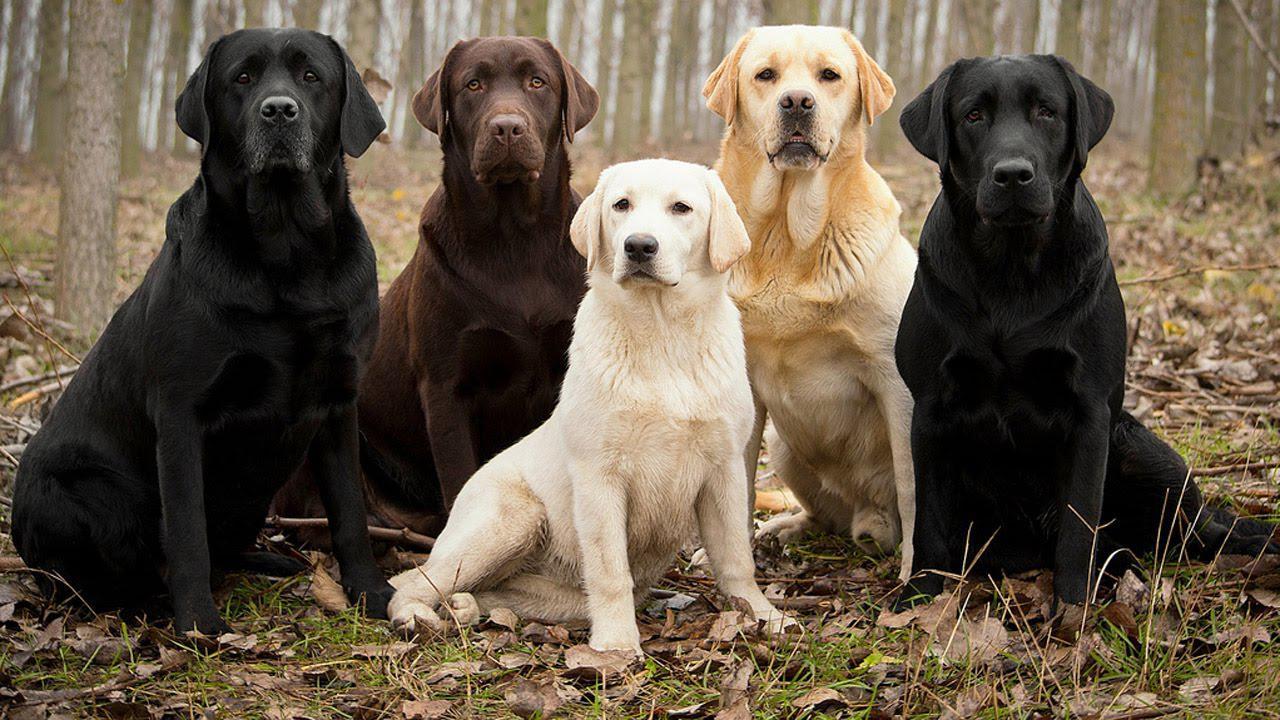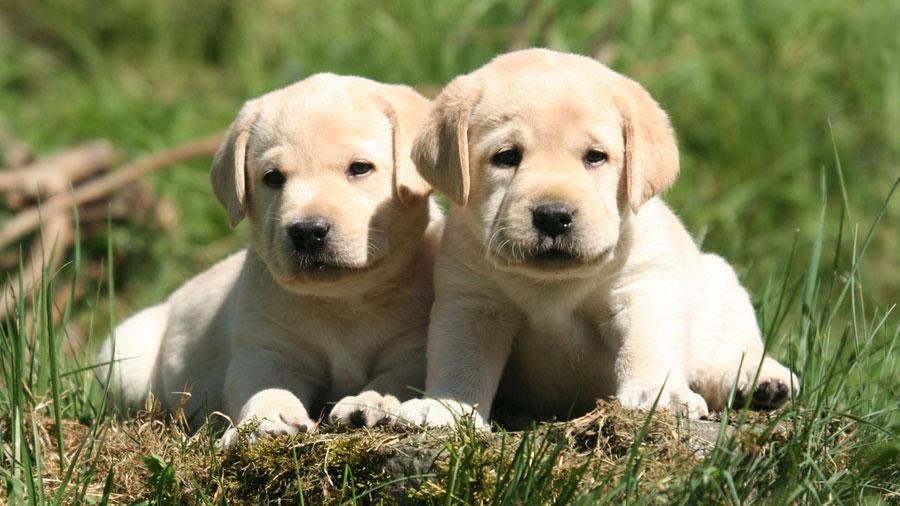The first image is the image on the left, the second image is the image on the right. For the images displayed, is the sentence "The left image contains more dogs than the right image." factually correct? Answer yes or no. Yes. The first image is the image on the left, the second image is the image on the right. Considering the images on both sides, is "In one image a group of dogs is four different colors, while in the other image, two dogs have the same coloring." valid? Answer yes or no. Yes. 